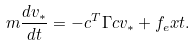<formula> <loc_0><loc_0><loc_500><loc_500>m \frac { d v _ { * } } { d t } = - c ^ { T } \Gamma c v _ { * } + f _ { e } x t .</formula> 